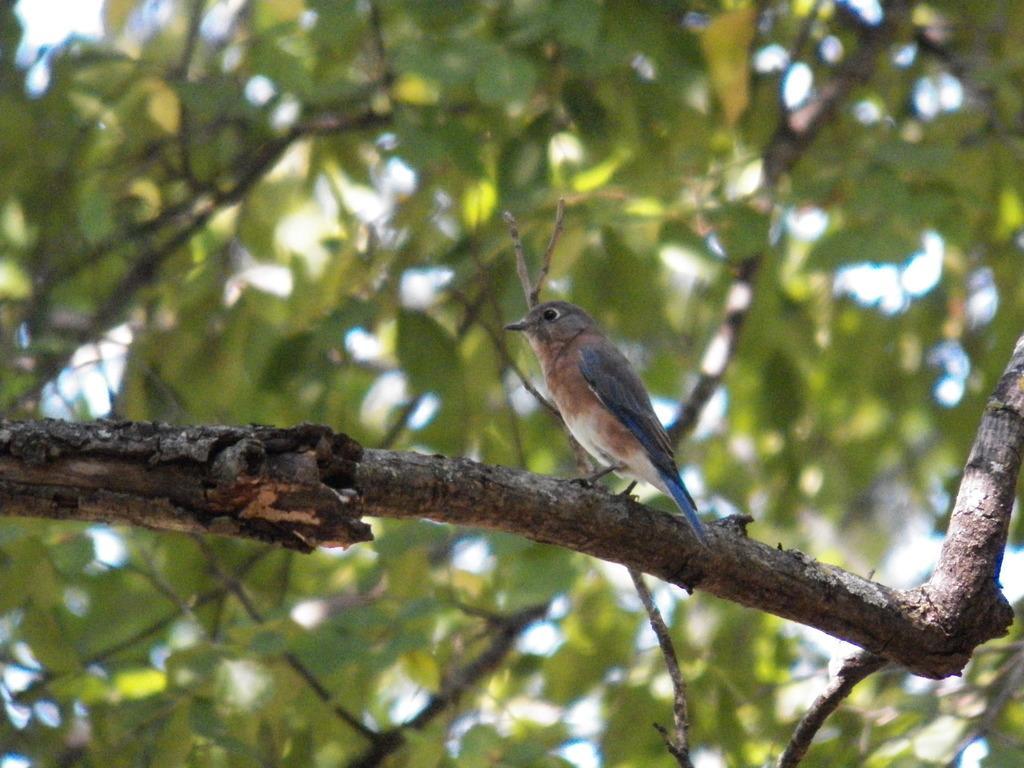Please provide a concise description of this image. In this image we can see a bird on a branch. In the background it is green and blur. 